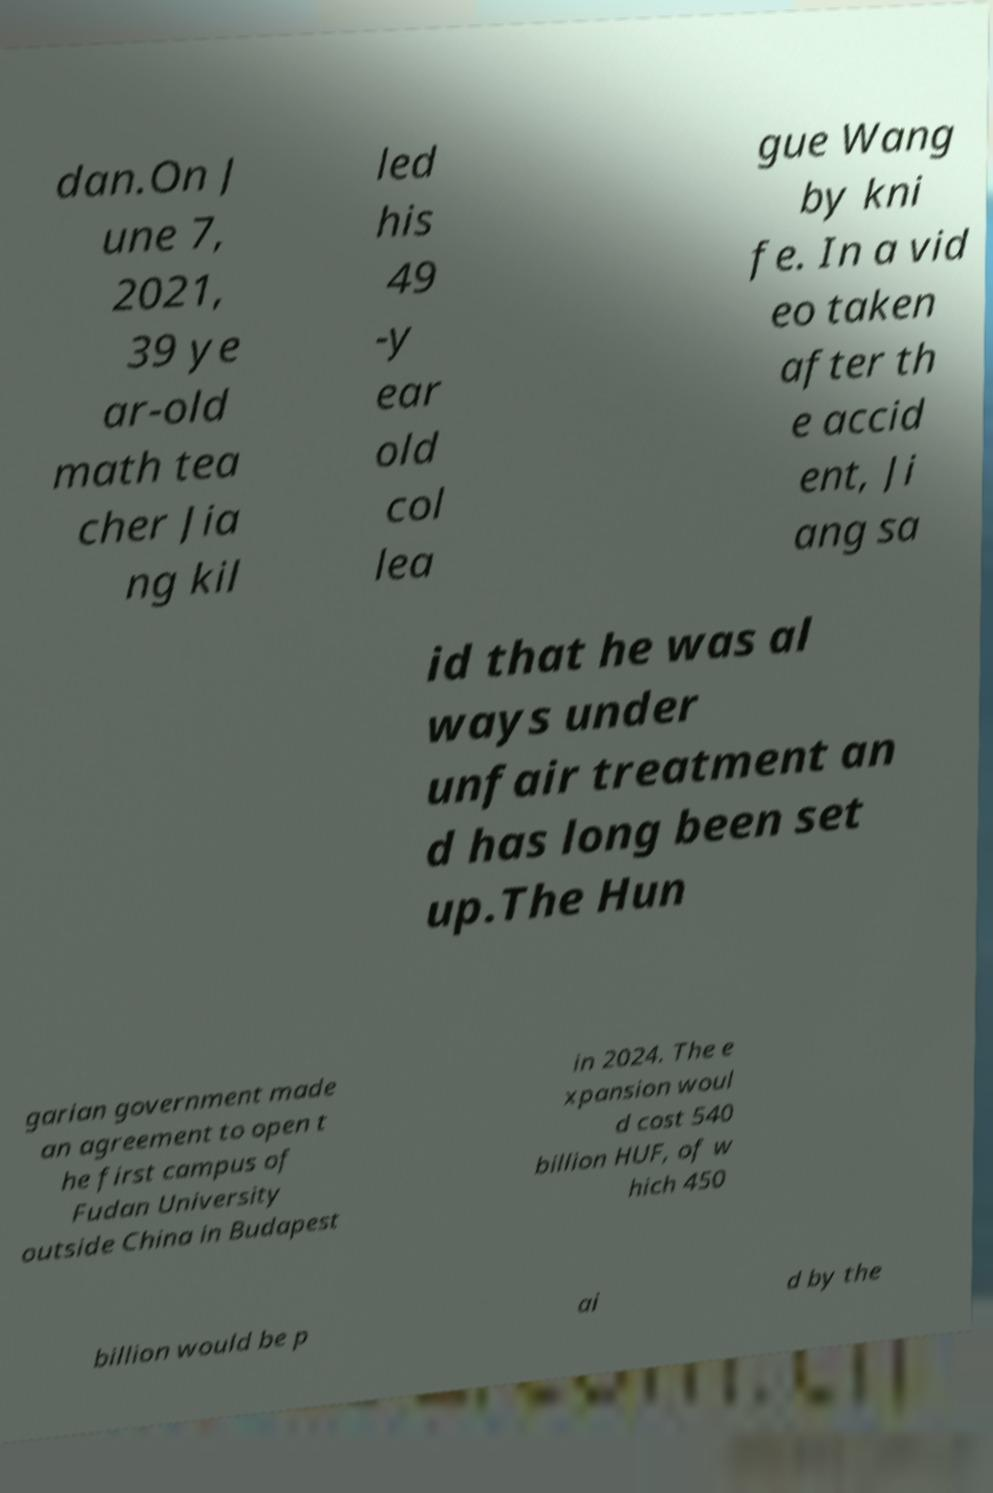Please read and relay the text visible in this image. What does it say? dan.On J une 7, 2021, 39 ye ar-old math tea cher Jia ng kil led his 49 -y ear old col lea gue Wang by kni fe. In a vid eo taken after th e accid ent, Ji ang sa id that he was al ways under unfair treatment an d has long been set up.The Hun garian government made an agreement to open t he first campus of Fudan University outside China in Budapest in 2024. The e xpansion woul d cost 540 billion HUF, of w hich 450 billion would be p ai d by the 